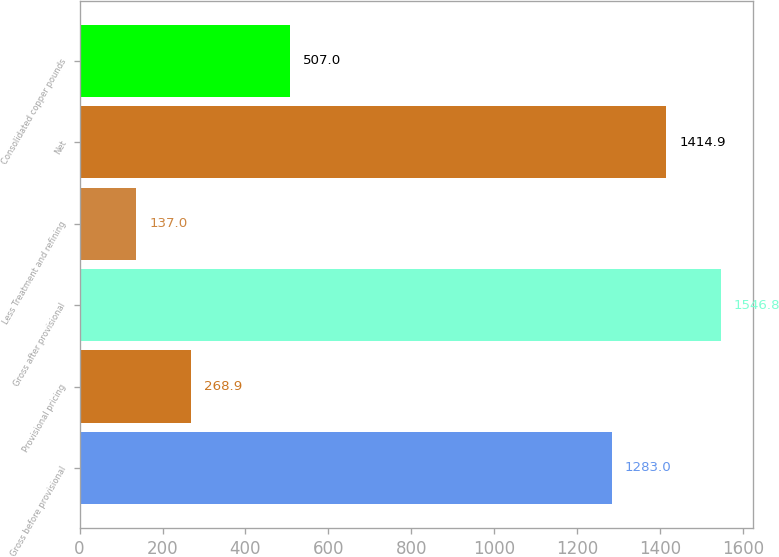Convert chart to OTSL. <chart><loc_0><loc_0><loc_500><loc_500><bar_chart><fcel>Gross before provisional<fcel>Provisional pricing<fcel>Gross after provisional<fcel>Less Treatment and refining<fcel>Net<fcel>Consolidated copper pounds<nl><fcel>1283<fcel>268.9<fcel>1546.8<fcel>137<fcel>1414.9<fcel>507<nl></chart> 